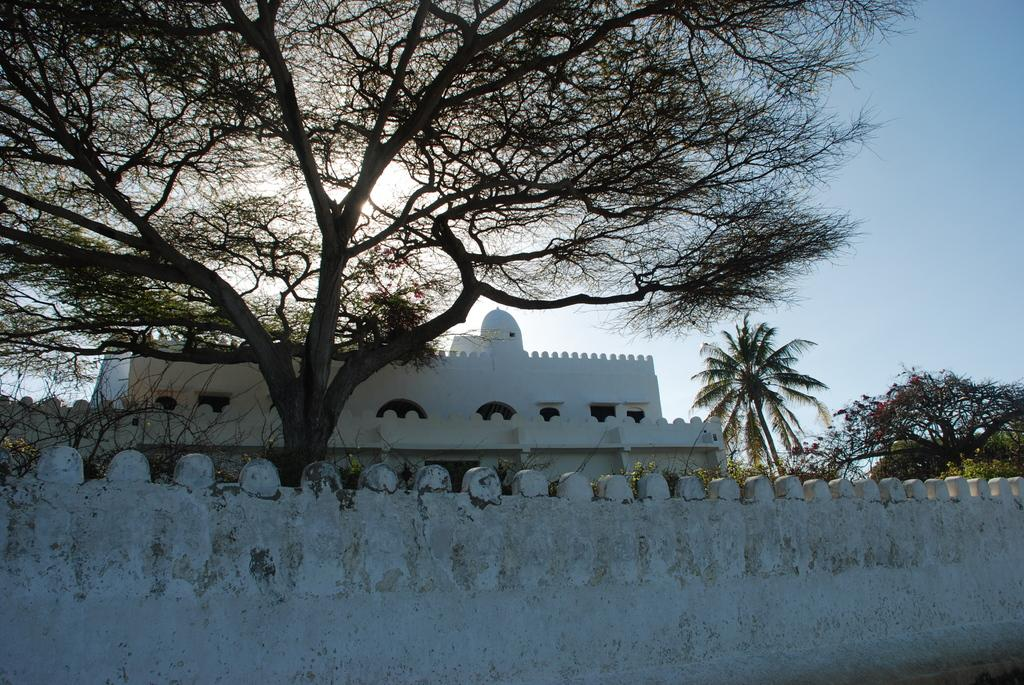What is the main structure visible in the image? There is a wall in the image. What can be seen behind the wall? Trees are visible behind the wall. Are there any other structures visible in the image? Yes, there is a building between the trees. What type of wood is used to construct the truck in the image? There is no truck present in the image, so it is not possible to determine the type of wood used in its construction. 